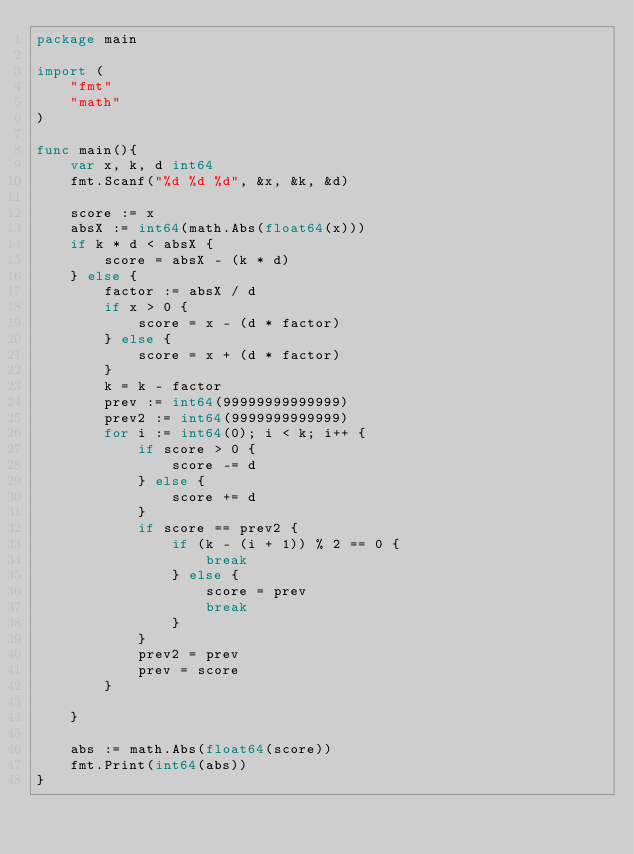<code> <loc_0><loc_0><loc_500><loc_500><_Go_>package main

import (
	"fmt"
	"math"
)

func main(){
	var x, k, d int64
	fmt.Scanf("%d %d %d", &x, &k, &d)

	score := x
	absX := int64(math.Abs(float64(x)))
	if k * d < absX {
		score = absX - (k * d)
	} else {
		factor := absX / d
		if x > 0 {
			score = x - (d * factor)
		} else {
			score = x + (d * factor)
		}
		k = k - factor
		prev := int64(99999999999999)
		prev2 := int64(9999999999999)
		for i := int64(0); i < k; i++ {
			if score > 0 {
				score -= d
			} else {
				score += d
			}
			if score == prev2 {
				if (k - (i + 1)) % 2 == 0 {
					break
				} else {
					score = prev
					break
				}
			}
			prev2 = prev
			prev = score
		}

	}

	abs := math.Abs(float64(score))
	fmt.Print(int64(abs))
}
</code> 